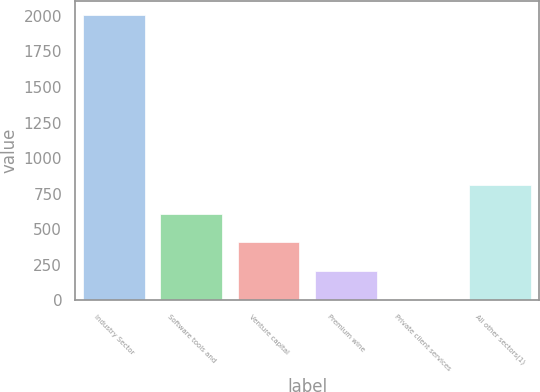Convert chart to OTSL. <chart><loc_0><loc_0><loc_500><loc_500><bar_chart><fcel>Industry Sector<fcel>Software tools and<fcel>Venture capital<fcel>Premium wine<fcel>Private client services<fcel>All other sectors(1)<nl><fcel>2005<fcel>608.64<fcel>409.16<fcel>209.68<fcel>10.2<fcel>808.12<nl></chart> 